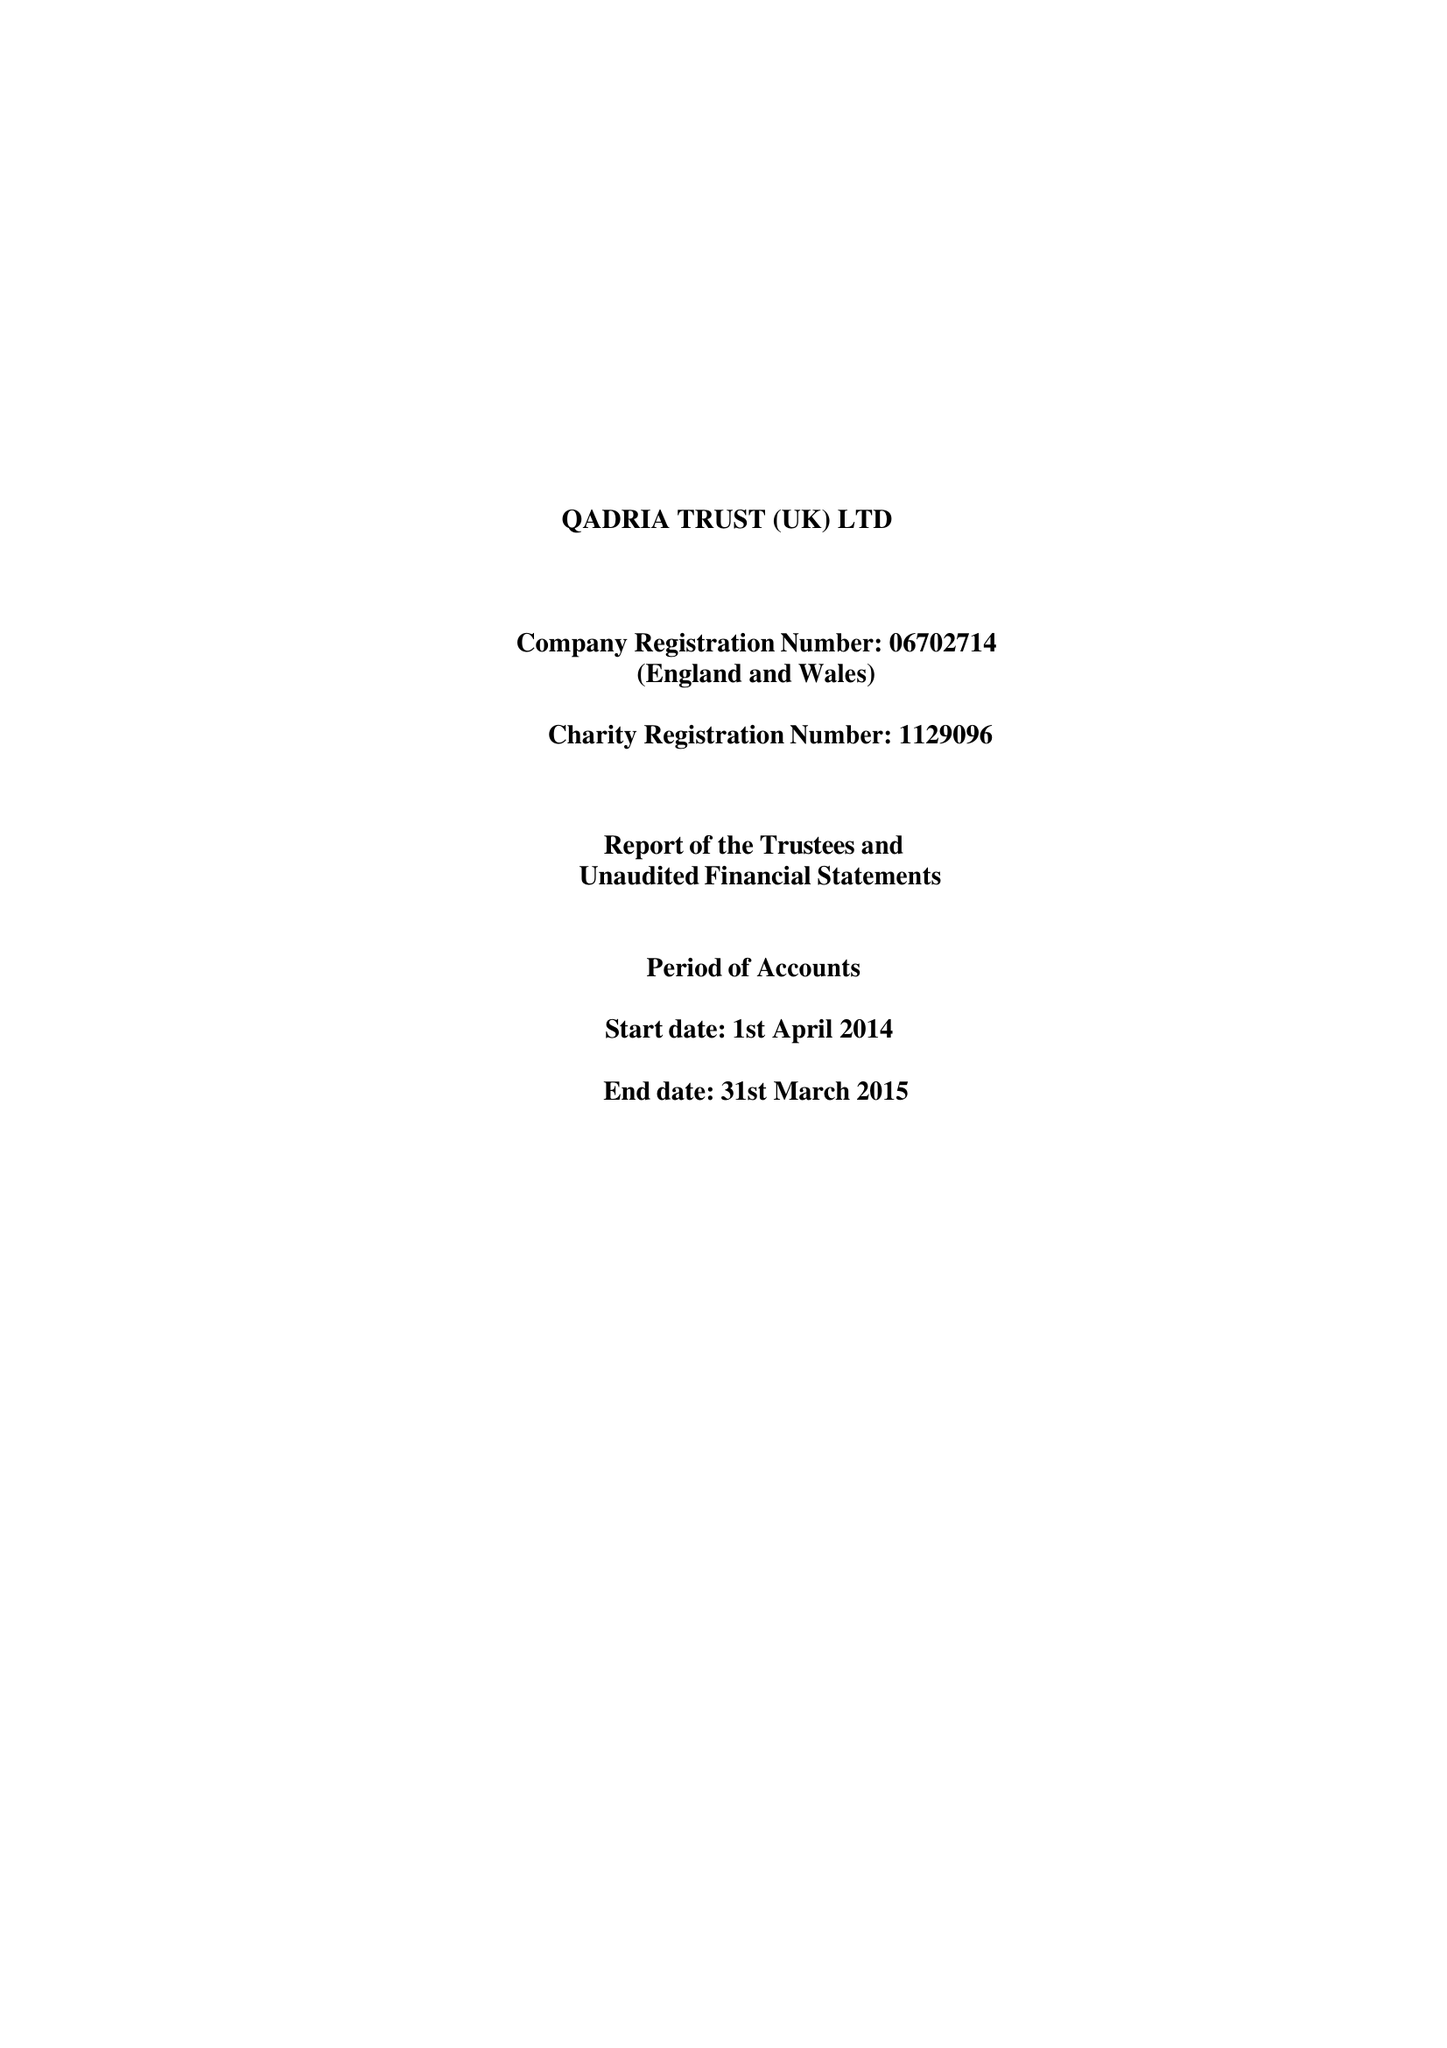What is the value for the report_date?
Answer the question using a single word or phrase. 2015-03-31 